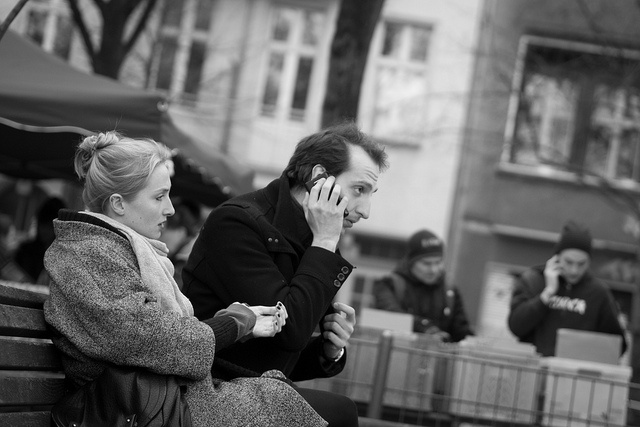Describe the objects in this image and their specific colors. I can see people in darkgray, gray, black, and lightgray tones, people in darkgray, black, gray, and lightgray tones, people in darkgray, black, gray, and lightgray tones, bench in black, gray, and darkgray tones, and people in darkgray, black, gray, and silver tones in this image. 